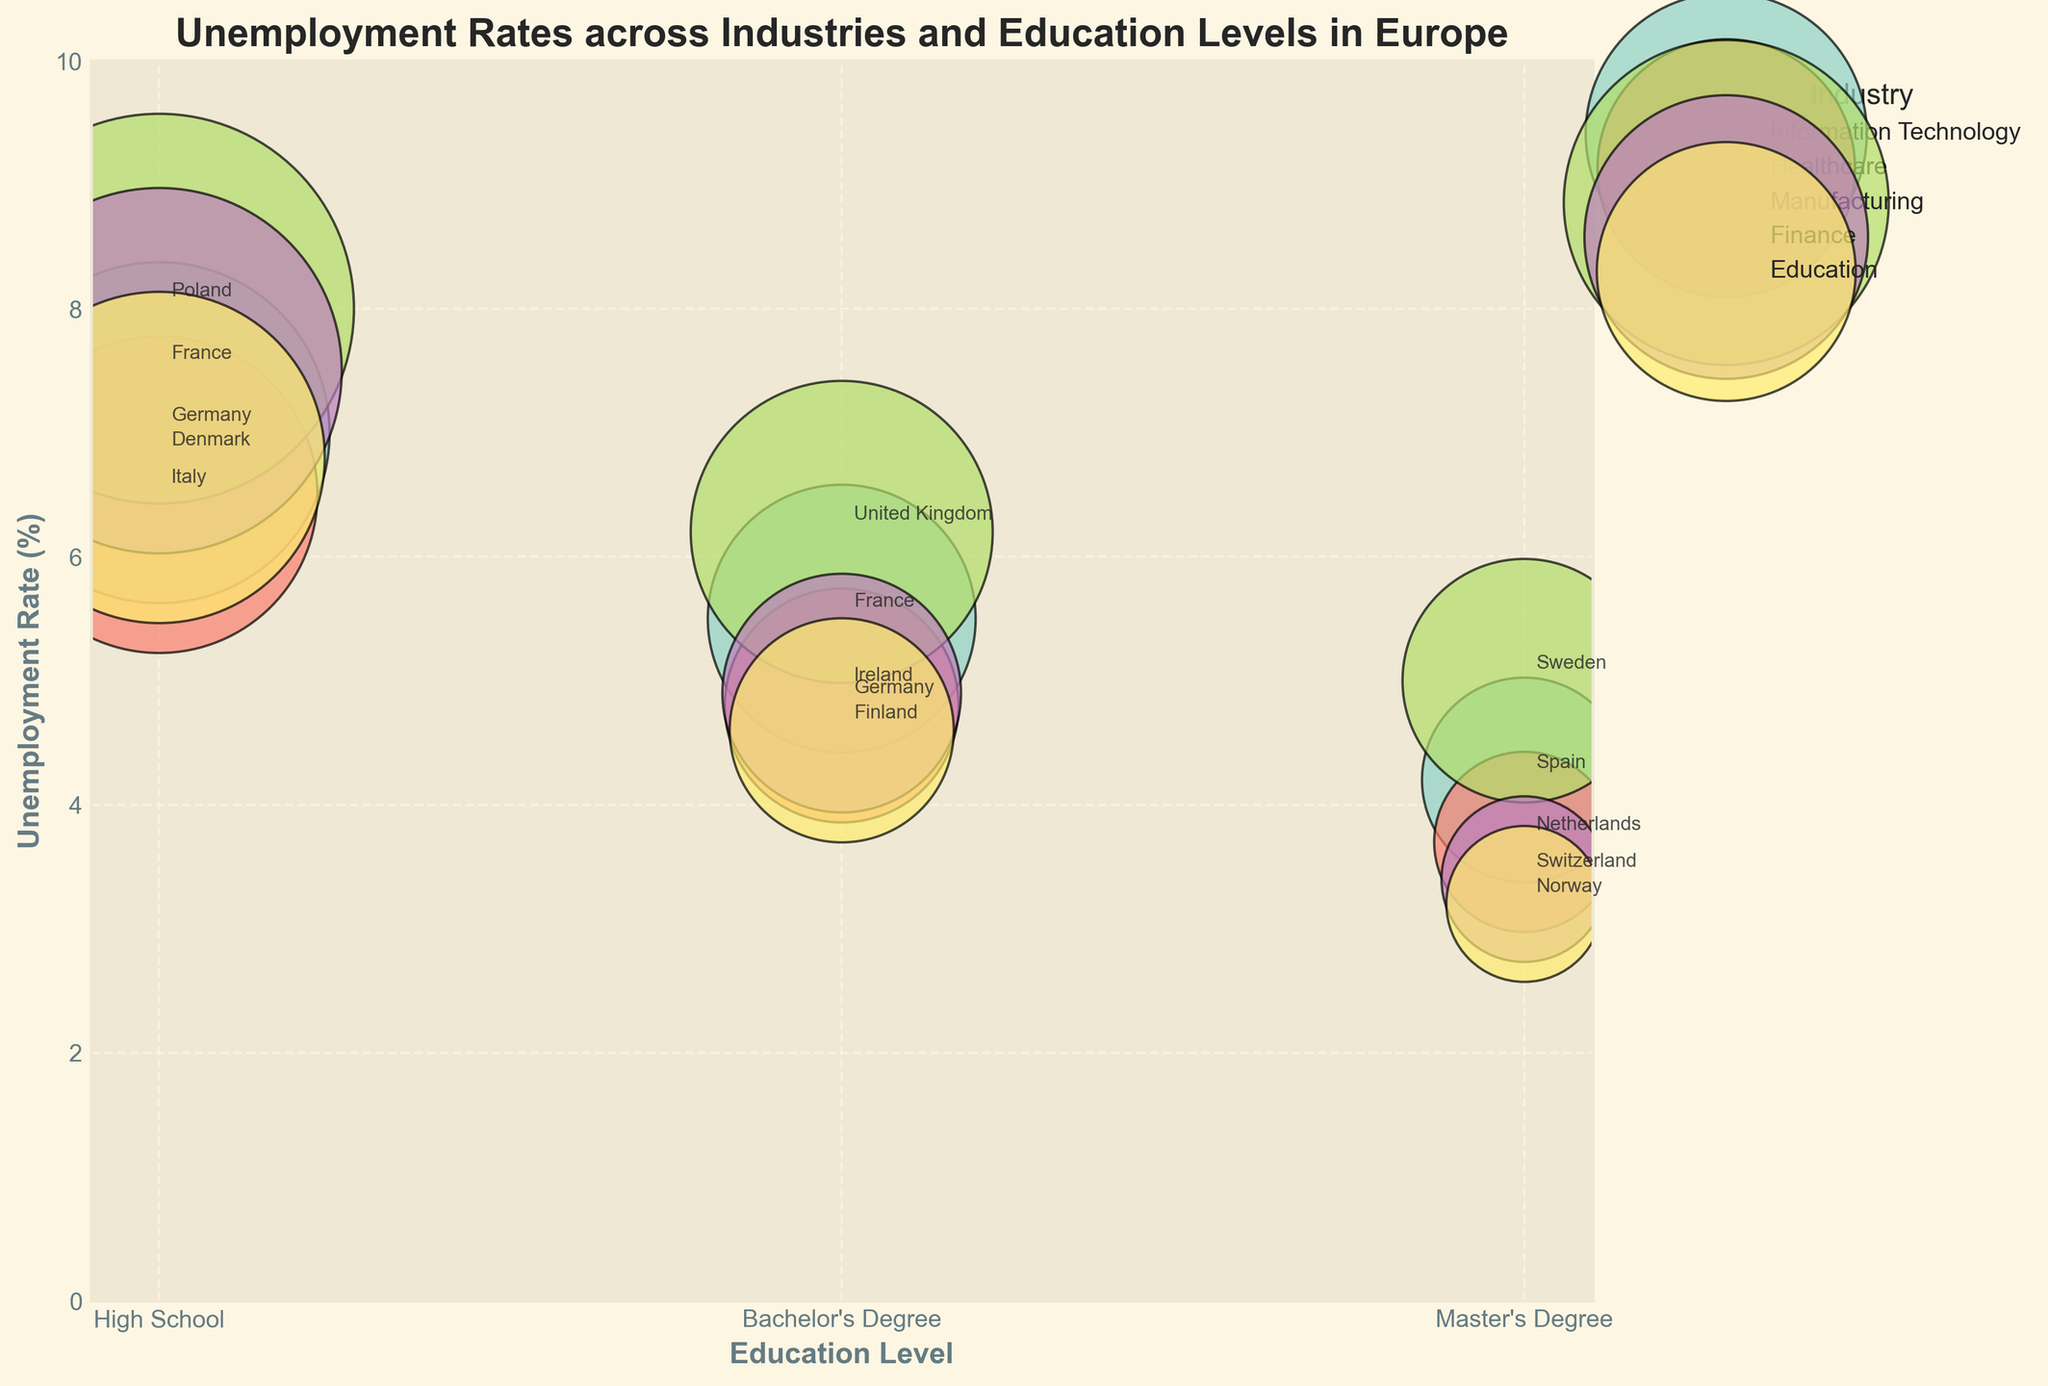What is the title of the chart? The title is typically displayed prominently at the top of the chart. In this case, it is the text at the top of the figure.
Answer: Unemployment Rates across Industries and Education Levels in Europe What are the axes labels? The axes labels are indicated on the x and y axes of the chart. Here, the x-axis is labeled 'Education Level' and the y-axis is labeled 'Unemployment Rate (%)'.
Answer: Education Level, Unemployment Rate (%) Which industry has the highest unemployment rate for Master's Degree level? Look for the bubble annotated with the 'Master's Degree' label on the x-axis and identify the highest bubble on the y-axis. The data shows it corresponds to Manufacturing in Sweden with an unemployment rate of 5.0%.
Answer: Manufacturing How many industries have their bubbles colored? Each industry has a unique color for its bubbles. By counting the distinct colors/legends on the chart, the number of industries can be determined.
Answer: 5 Which country has the lowest unemployment rate for the Finance industry? Locate the 'Finance' industry bubbles and identify the smallest bubble on the chart. The label on this bubble shows Switzerland with a 3.4% unemployment rate.
Answer: Switzerland What is the difference in unemployment rates between Bachelor's Degree and Master’s Degree in Education? Confer the bubbles in the 'Education' industry for Bachelor's and Master's Degree levels. Subtract the unemployment rate of Master's Degree (3.2%) from that of Bachelor's Degree (4.6%).
Answer: 1.4% Compare the unemployment rates of Information Technology and Healthcare for High School education. Which is higher? Look for the bubbles under 'High School' for both 'Information Technology' and 'Healthcare'. Compare their y-axis values. Information Technology (7.0%) is higher than Healthcare (6.5%).
Answer: Information Technology What is the average unemployment rate for the Healthcare industry across all education levels? Identify the unemployment rates for Healthcare (6.5% for High School, 4.8% for Bachelor's Degree, and 3.7% for Master's Degree). Sum them (6.5 + 4.8 + 3.7 = 15) and divide by the number of education levels (3).
Answer: 5.0% What does each bubble represent in the bubble chart? The bubbles in the bubble chart represent the unemployment rates in various industries for different education levels. Each bubble's size correlates with the magnitude of the unemployment rate, and they are color-coded by industry.
Answer: An industry-education level combination with its unemployment rate Which industry has the smallest bubble, and what does it indicate? Locate the smallest bubble visually and note its color/label. The smallest bubble belongs to the Finance industry for Master's Degree in Switzerland with a 3.4% unemployment rate, indicating the lowest unemployment rate in the dataset.
Answer: Finance, low unemployment rate 